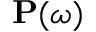<formula> <loc_0><loc_0><loc_500><loc_500>\mathbf P ( \omega )</formula> 